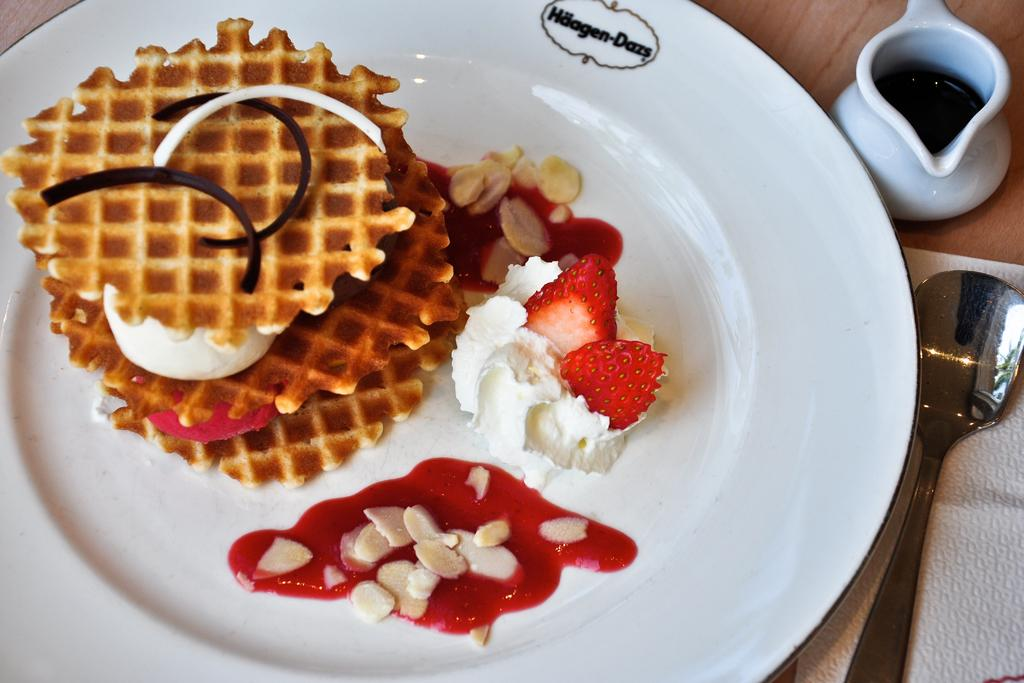What is on the plate in the image? There are food items on a plate in the image. What utensil is visible in the image? There is a spoon visible in the image. What else can be seen on the table in the image? There is a cup on the table in the image. What type of glove is being used to handle the food items in the image? There is no glove present in the image; the food items are being handled with a spoon. 